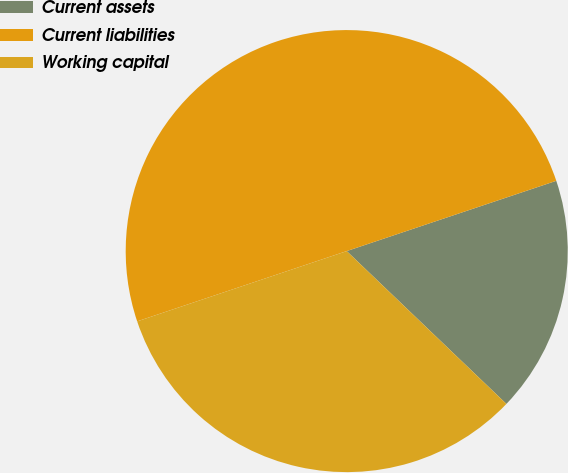Convert chart. <chart><loc_0><loc_0><loc_500><loc_500><pie_chart><fcel>Current assets<fcel>Current liabilities<fcel>Working capital<nl><fcel>17.3%<fcel>50.0%<fcel>32.7%<nl></chart> 